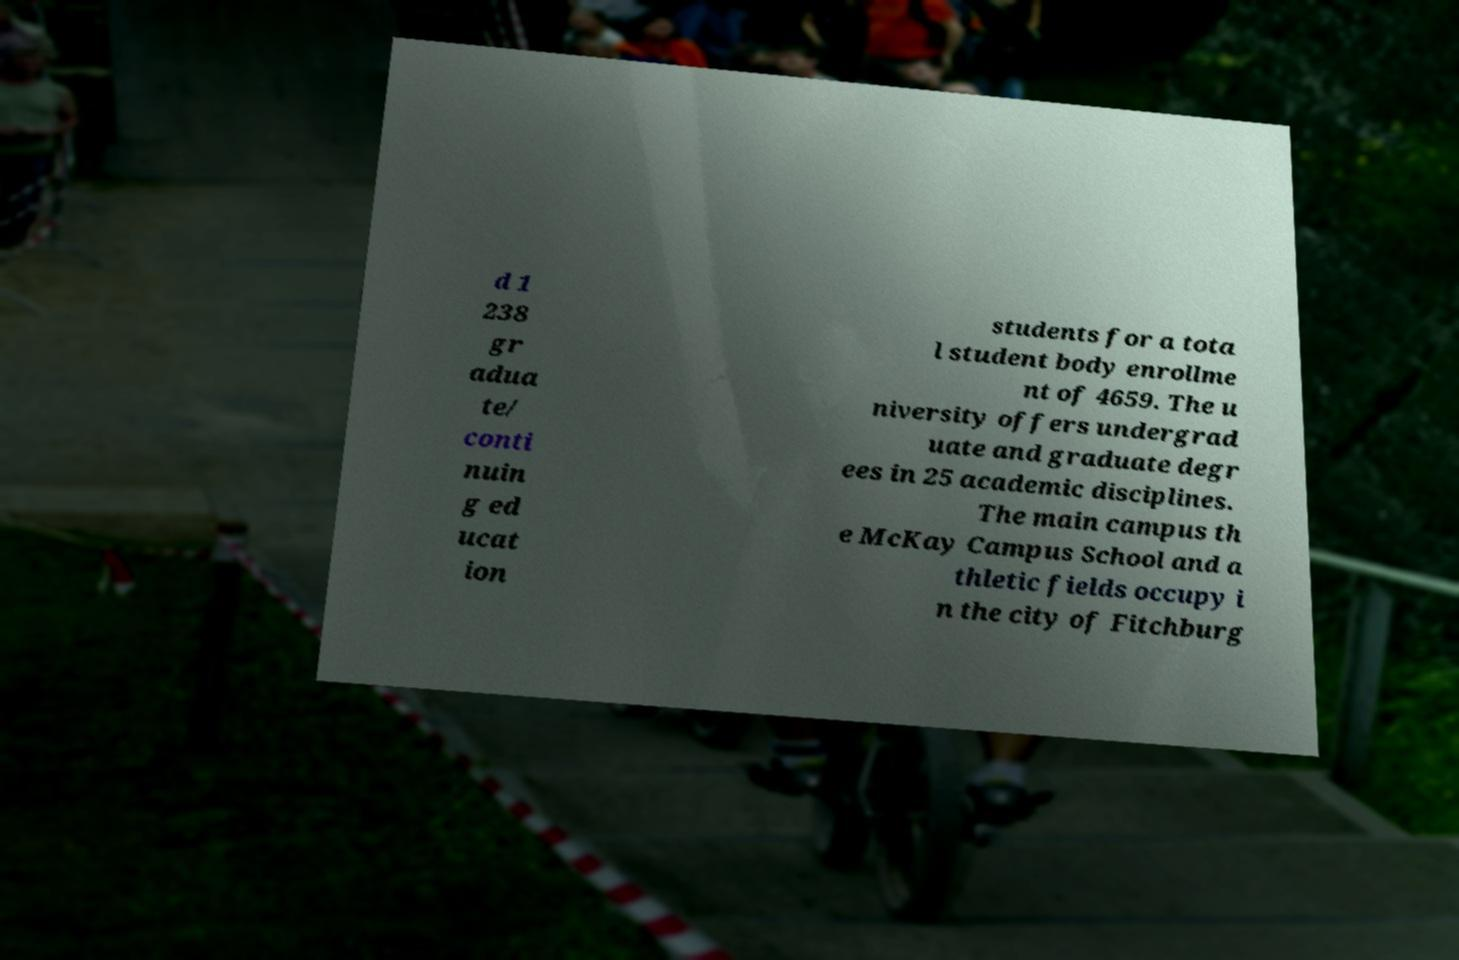Could you assist in decoding the text presented in this image and type it out clearly? d 1 238 gr adua te/ conti nuin g ed ucat ion students for a tota l student body enrollme nt of 4659. The u niversity offers undergrad uate and graduate degr ees in 25 academic disciplines. The main campus th e McKay Campus School and a thletic fields occupy i n the city of Fitchburg 